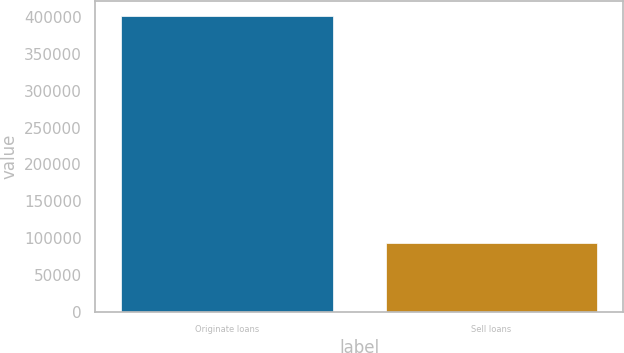Convert chart to OTSL. <chart><loc_0><loc_0><loc_500><loc_500><bar_chart><fcel>Originate loans<fcel>Sell loans<nl><fcel>402174<fcel>92655<nl></chart> 